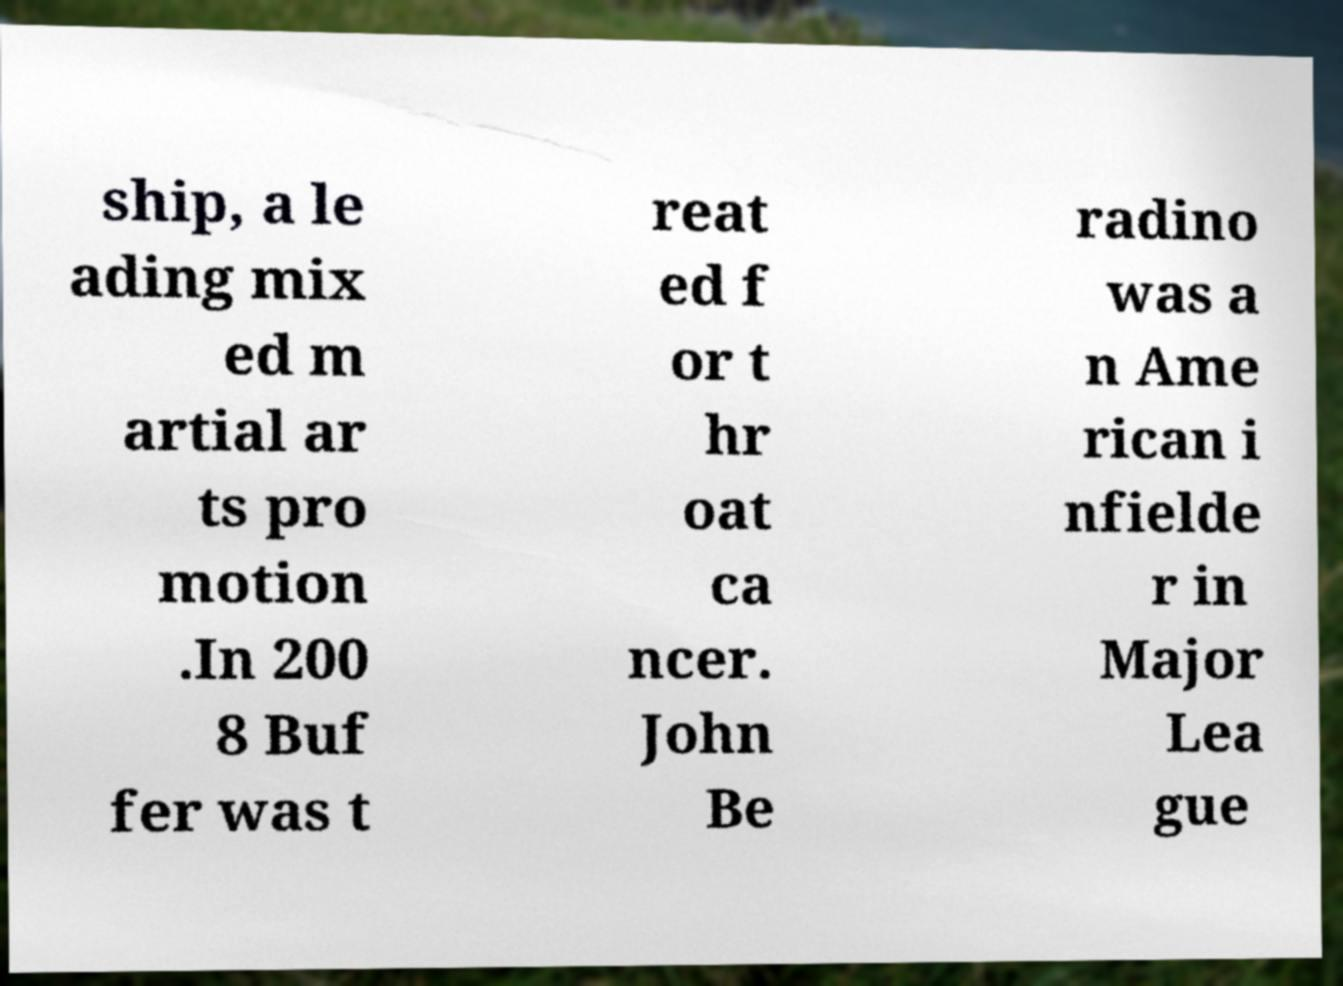I need the written content from this picture converted into text. Can you do that? ship, a le ading mix ed m artial ar ts pro motion .In 200 8 Buf fer was t reat ed f or t hr oat ca ncer. John Be radino was a n Ame rican i nfielde r in Major Lea gue 